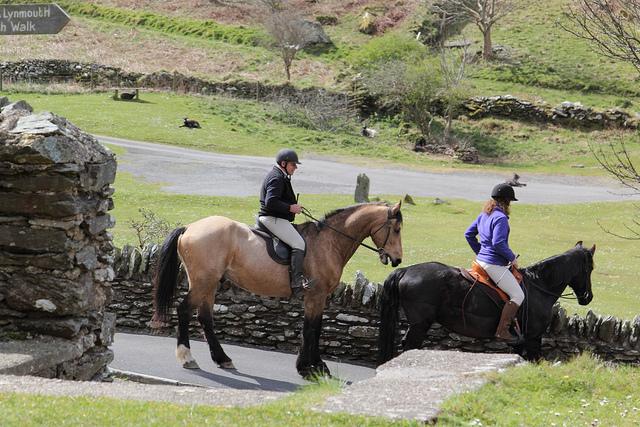What are they standing on?
Write a very short answer. Horses. Do these people know each other?
Keep it brief. Yes. How many horses are in the picture?
Quick response, please. 2. How many horses are there in the image?
Write a very short answer. 2. Are they riding in the countryside?
Write a very short answer. Yes. What sound would these animals make?
Answer briefly. Neigh. What are the people riding?
Write a very short answer. Horses. 